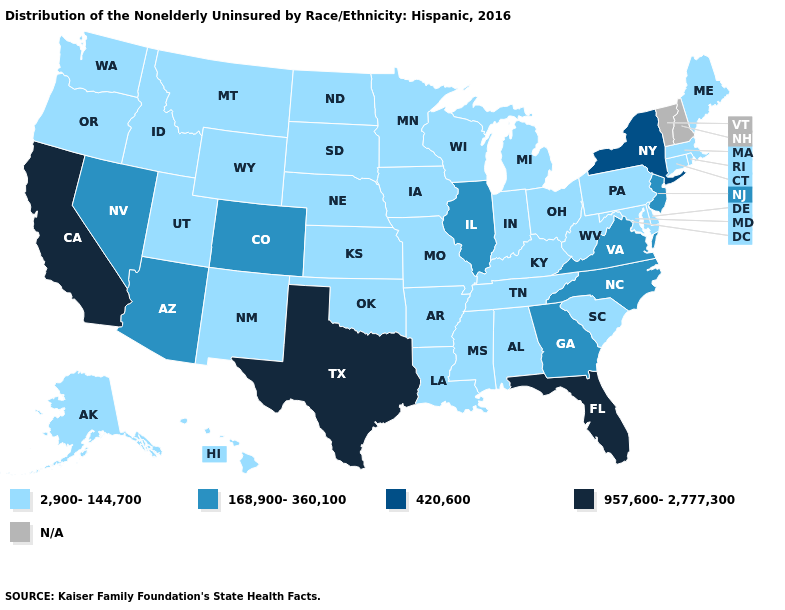Name the states that have a value in the range 957,600-2,777,300?
Be succinct. California, Florida, Texas. Which states have the highest value in the USA?
Write a very short answer. California, Florida, Texas. Does Tennessee have the lowest value in the USA?
Short answer required. Yes. Name the states that have a value in the range N/A?
Answer briefly. New Hampshire, Vermont. Does the first symbol in the legend represent the smallest category?
Short answer required. Yes. What is the highest value in the MidWest ?
Concise answer only. 168,900-360,100. Name the states that have a value in the range N/A?
Concise answer only. New Hampshire, Vermont. What is the lowest value in states that border Kansas?
Answer briefly. 2,900-144,700. Name the states that have a value in the range N/A?
Give a very brief answer. New Hampshire, Vermont. Name the states that have a value in the range 168,900-360,100?
Quick response, please. Arizona, Colorado, Georgia, Illinois, Nevada, New Jersey, North Carolina, Virginia. Among the states that border Idaho , which have the highest value?
Short answer required. Nevada. What is the value of Nebraska?
Answer briefly. 2,900-144,700. Name the states that have a value in the range N/A?
Write a very short answer. New Hampshire, Vermont. 